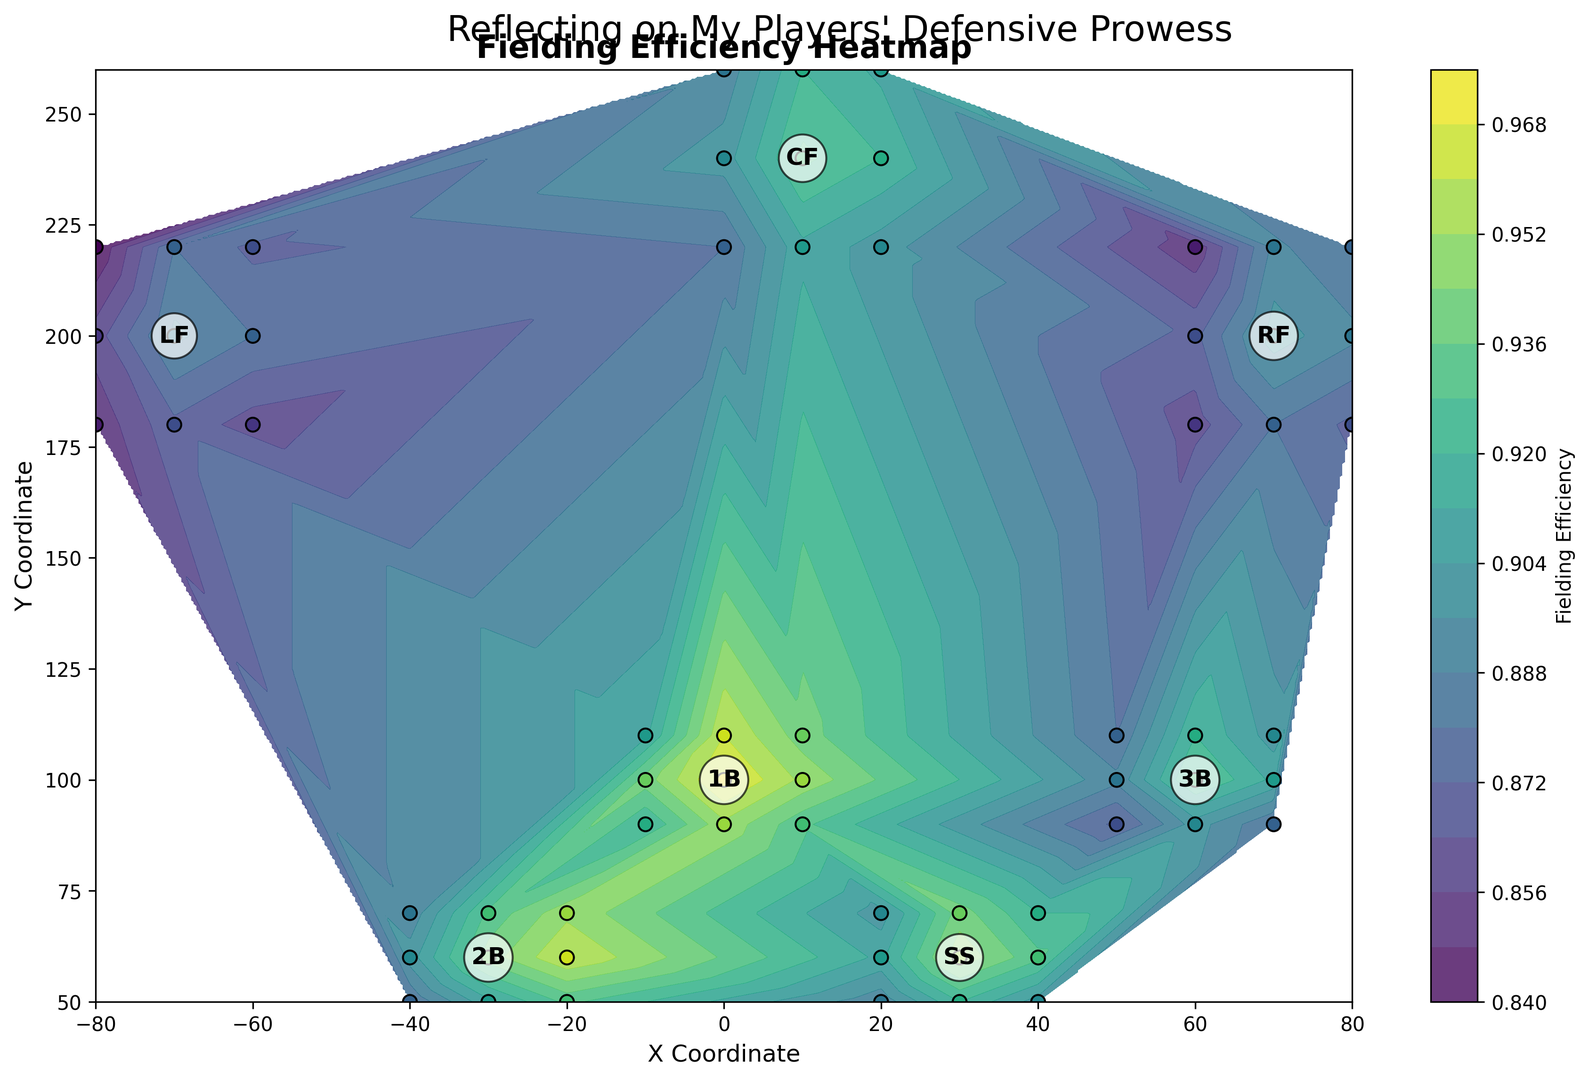What's the highest efficiency observed for the first baseman (1B)? First, locate the positions labeled as '1B'. These are around the coordinates (0, 100). Look at the color intensity and refer to the color bar, then check the highest intensity which represents the highest efficiency. The highest value close to 0.97.
Answer: 0.97 How does the efficiency of shortstop (SS) compare to second baseman (2B) at their most efficient points? Look for the positions labeled 'SS' and '2B'. Check the efficiency values around these positions, particularly the highest values. Shortstop's highest efficiency is 0.95 and second baseman's highest efficiency is 0.96. Compare these values directly.
Answer: Second baseman (2B) is more efficient Which position has the lowest fielding efficiency, and what is the value? Scan the entire plot for the darkest regions which represent the lowest efficiency values. This appears around left field (LF) at around coordinates (-70, 200) with a value close to 0.84.
Answer: Left Field (LF), 0.84 Compare the efficiency of center fielder (CF) and right fielder (RF) at their maximum efficiency points. Locate 'CF' around coordinates (10, 240) and 'RF' around coordinates (70, 200). Identify their highest efficiency values from the plot. For CF, it is 0.93 and for RF, it is 0.90.
Answer: Center fielder (CF) is more efficient What is the average efficiency between the second baseman (2B) and third baseman (3B) at their respective positions? Identify the positions for 2B (-30, 60) and 3B (60, 100). Sum their efficiency values and divide by the number of observations (9 for 2B and 9 for 3B). Compute (0.88+0.91+0.93+0.90+0.94+0.96+0.89+0.93+0.95 + 0.87+0.90+0.88+0.89+0.93+0.91+0.88+0.92+0.90)/18 = 0.9125.
Answer: 0.91 Where do we see the largest variation in fielding efficiency within a single position? Check each position's color gradients within its area. Look for areas with the most significant change from dark to light shades. This is likely seen for CF and LF positions, having larger gradients than others.
Answer: Center Field (CF) or Left Field (LF) Between first baseman (1B) and third baseman (3B), who has a more consistent fielding efficiency? Compare the color gradients within the areas labeled '1B' and '3B'. 1B appears lighter and more uniform than 3B, which has slight variations from darker to lighter. Consistency reflects less variation.
Answer: First baseman (1B) Which outfield position has the highest average efficiency, and what is the value? Identify the outfield positions (LF, CF, RF). Calculate the average efficiency for each position. LF: 0.85, 0.87, 0.86, 0.86, 0.89, 0.88, 0.84, 0.88, 0.87; CF: 0.88, 0.91, 0.90, 0.90, 0.93, 0.92, 0.89, 0.92, 0.91; RF: 0.86, 0.88, 0.87, 0.87, 0.90, 0.89, 0.85, 0.89, 0.88. Calculate the average of each: LF (0.866), CF (0.904), RF (0.877).
Answer: Center Field (CF), 0.904 What's the efficiency difference between the highest and lowest values in the infield positions? First, find the highest and lowest efficiency values within the infield positions (1B, 2B, SS, 3B). Highest (1B): 0.97, Lowest (3B): 0.87. Difference: 0.97 - 0.87.
Answer: 0.10 